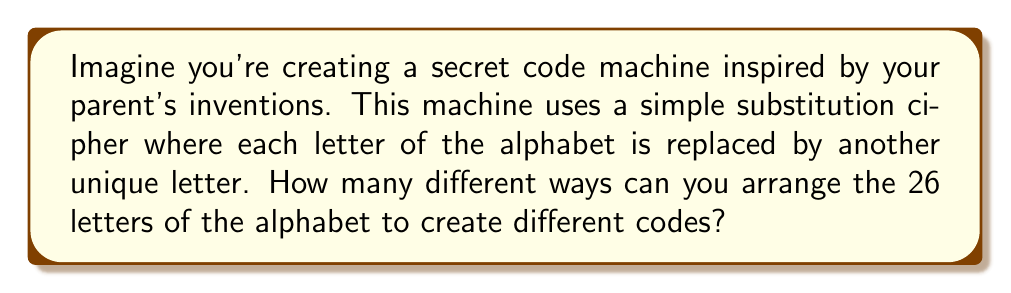Can you solve this math problem? Let's approach this step-by-step:

1) In a simple substitution cipher, each letter of the alphabet is replaced by another letter, and no two letters can be replaced by the same letter.

2) This means we're essentially arranging all 26 letters of the alphabet in different orders.

3) This is a perfect scenario for using permutations. We're arranging all 26 letters, and the order matters.

4) The formula for permutations of n distinct objects is:

   $$P(n) = n!$$

   Where $n!$ represents the factorial of n.

5) In this case, $n = 26$ (for the 26 letters of the alphabet).

6) So, we need to calculate:

   $$26! = 26 \times 25 \times 24 \times ... \times 3 \times 2 \times 1$$

7) This is a very large number. Let's calculate it:

   $$26! = 403,291,461,126,605,635,584,000,000$$

This means there are over 403 septillion different ways to arrange the alphabet for your secret code machine!
Answer: $26! = 403,291,461,126,605,635,584,000,000$ 